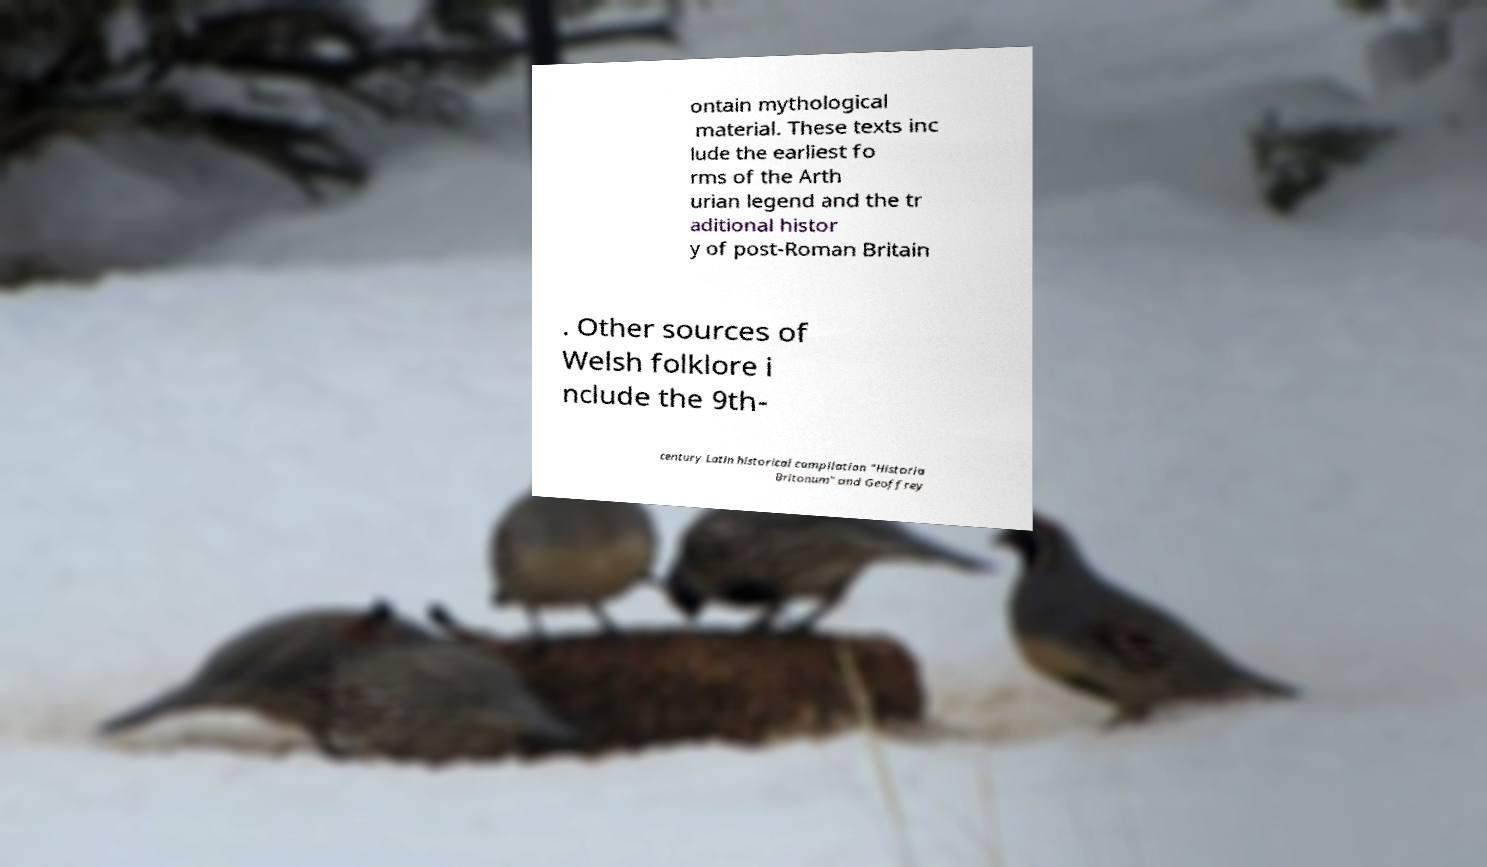Please read and relay the text visible in this image. What does it say? ontain mythological material. These texts inc lude the earliest fo rms of the Arth urian legend and the tr aditional histor y of post-Roman Britain . Other sources of Welsh folklore i nclude the 9th- century Latin historical compilation "Historia Britonum" and Geoffrey 